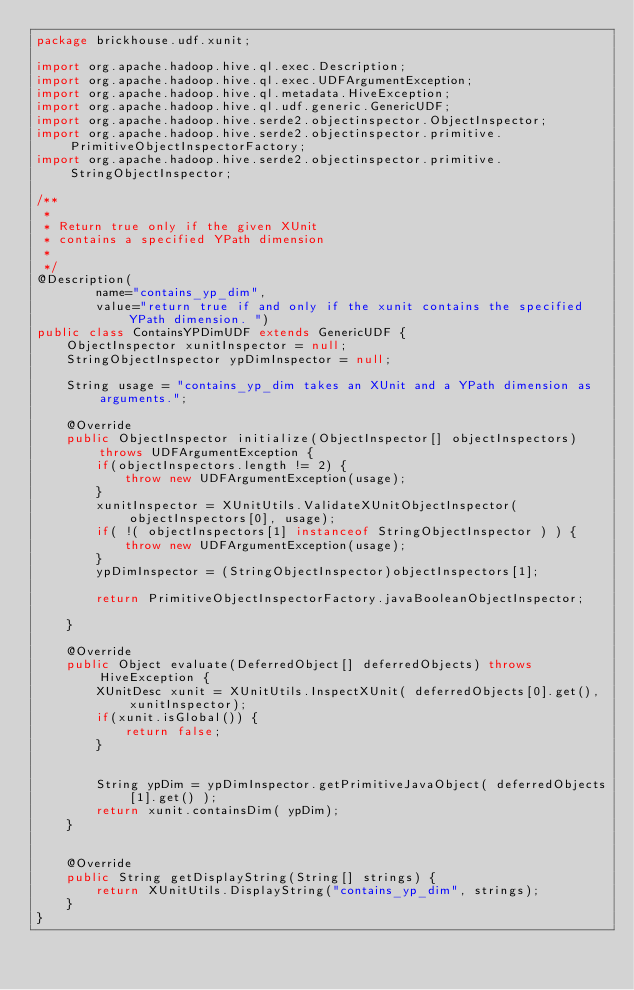<code> <loc_0><loc_0><loc_500><loc_500><_Java_>package brickhouse.udf.xunit;

import org.apache.hadoop.hive.ql.exec.Description;
import org.apache.hadoop.hive.ql.exec.UDFArgumentException;
import org.apache.hadoop.hive.ql.metadata.HiveException;
import org.apache.hadoop.hive.ql.udf.generic.GenericUDF;
import org.apache.hadoop.hive.serde2.objectinspector.ObjectInspector;
import org.apache.hadoop.hive.serde2.objectinspector.primitive.PrimitiveObjectInspectorFactory;
import org.apache.hadoop.hive.serde2.objectinspector.primitive.StringObjectInspector;

/**
 *
 * Return true only if the given XUnit
 * contains a specified YPath dimension
 *
 */
@Description(
        name="contains_yp_dim",
        value="return true if and only if the xunit contains the specified YPath dimension. ")
public class ContainsYPDimUDF extends GenericUDF {
    ObjectInspector xunitInspector = null;
    StringObjectInspector ypDimInspector = null;

    String usage = "contains_yp_dim takes an XUnit and a YPath dimension as arguments.";

    @Override
    public ObjectInspector initialize(ObjectInspector[] objectInspectors) throws UDFArgumentException {
        if(objectInspectors.length != 2) {
            throw new UDFArgumentException(usage);
        }
        xunitInspector = XUnitUtils.ValidateXUnitObjectInspector(objectInspectors[0], usage);
        if( !( objectInspectors[1] instanceof StringObjectInspector ) ) {
            throw new UDFArgumentException(usage);
        }
        ypDimInspector = (StringObjectInspector)objectInspectors[1];

        return PrimitiveObjectInspectorFactory.javaBooleanObjectInspector;

    }

    @Override
    public Object evaluate(DeferredObject[] deferredObjects) throws HiveException {
        XUnitDesc xunit = XUnitUtils.InspectXUnit( deferredObjects[0].get(), xunitInspector);
        if(xunit.isGlobal()) {
            return false;
        }


        String ypDim = ypDimInspector.getPrimitiveJavaObject( deferredObjects[1].get() );
        return xunit.containsDim( ypDim);
    }


    @Override
    public String getDisplayString(String[] strings) {
        return XUnitUtils.DisplayString("contains_yp_dim", strings);
    }
}
</code> 